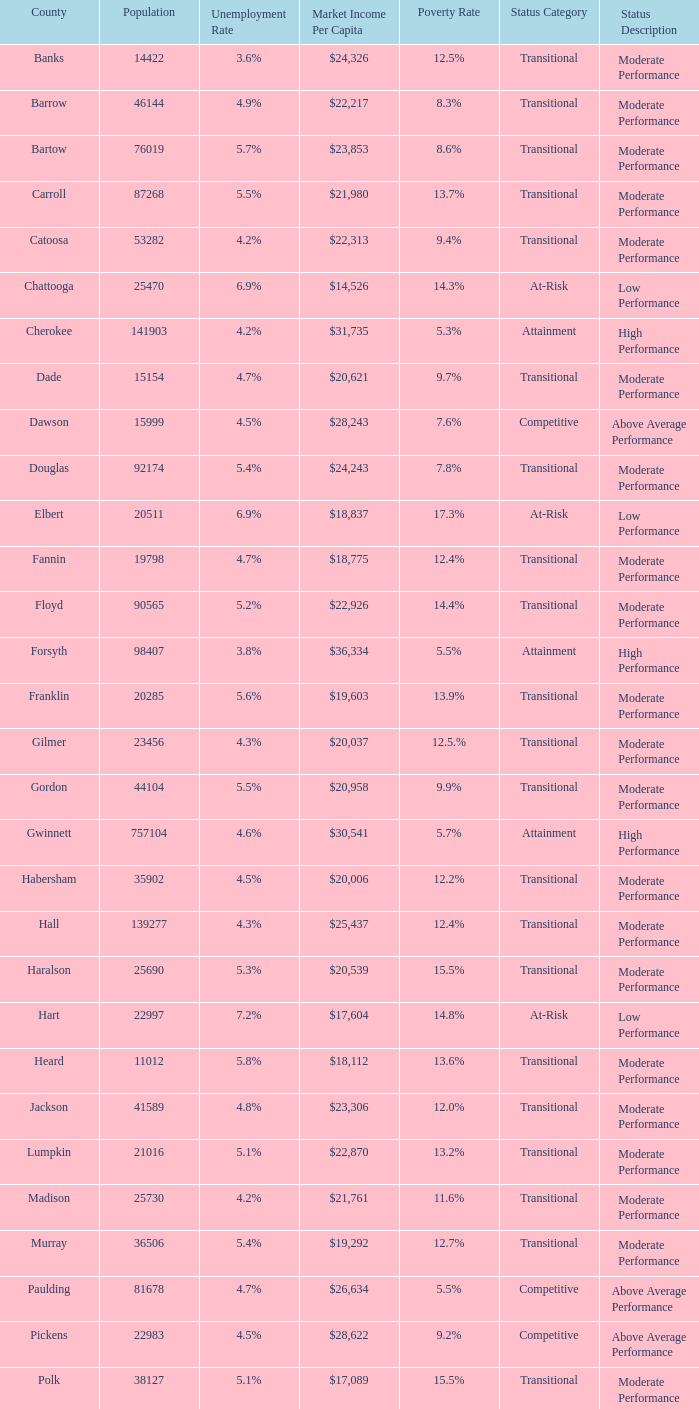How many status' are there with a population of 90565? 1.0. 